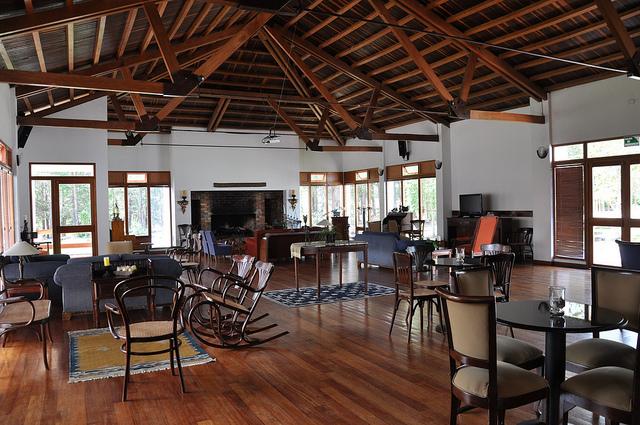What substance is the floor made from?
Write a very short answer. Wood. Is this an open floor plan?
Be succinct. Yes. How many people are in the room?
Give a very brief answer. 0. What is the floor made of?
Be succinct. Wood. 